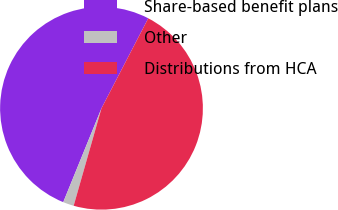<chart> <loc_0><loc_0><loc_500><loc_500><pie_chart><fcel>Share-based benefit plans<fcel>Other<fcel>Distributions from HCA<nl><fcel>51.48%<fcel>1.73%<fcel>46.8%<nl></chart> 